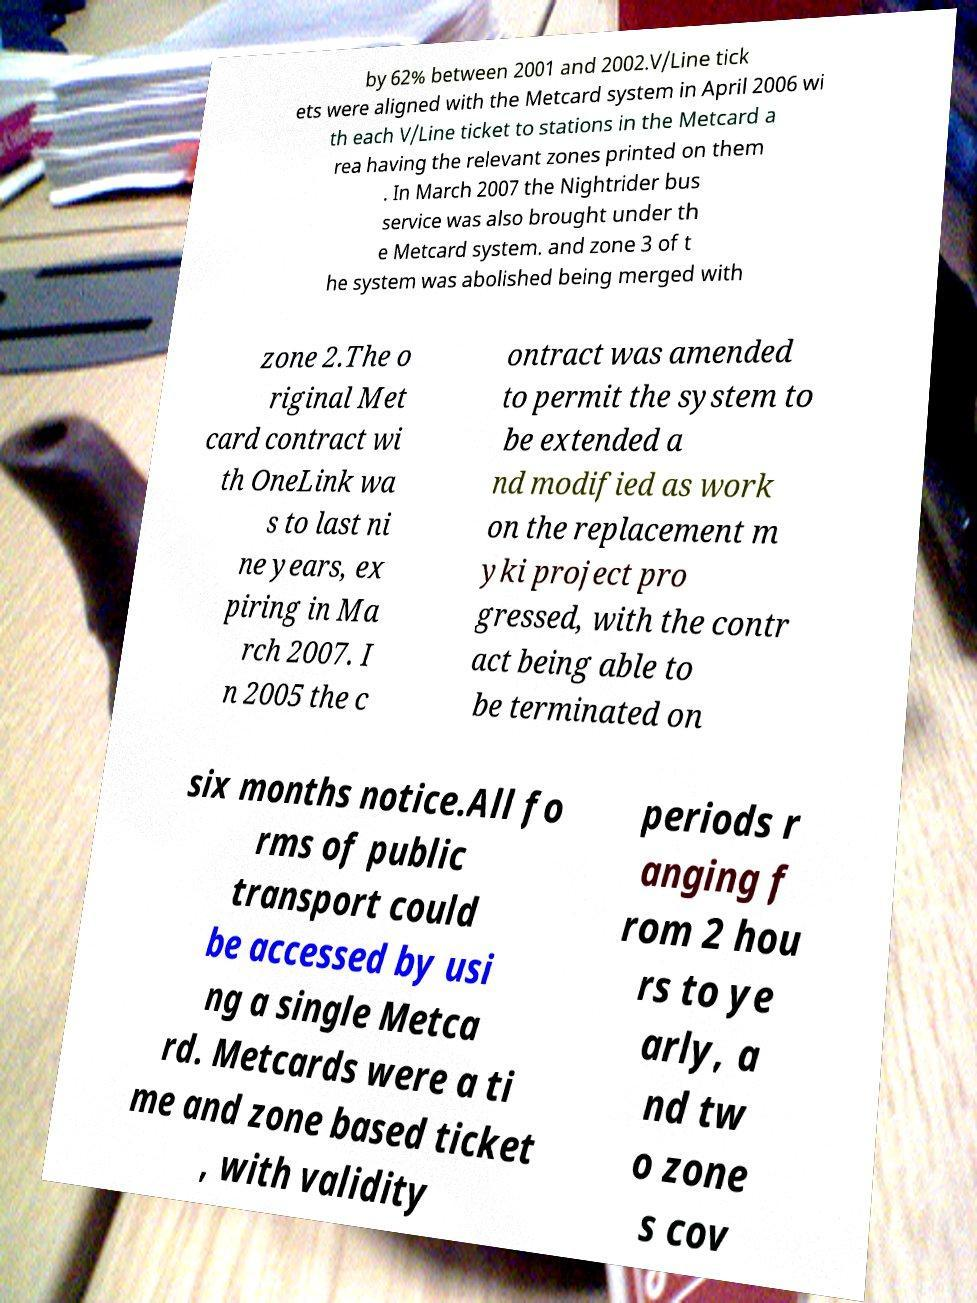Can you accurately transcribe the text from the provided image for me? by 62% between 2001 and 2002.V/Line tick ets were aligned with the Metcard system in April 2006 wi th each V/Line ticket to stations in the Metcard a rea having the relevant zones printed on them . In March 2007 the Nightrider bus service was also brought under th e Metcard system. and zone 3 of t he system was abolished being merged with zone 2.The o riginal Met card contract wi th OneLink wa s to last ni ne years, ex piring in Ma rch 2007. I n 2005 the c ontract was amended to permit the system to be extended a nd modified as work on the replacement m yki project pro gressed, with the contr act being able to be terminated on six months notice.All fo rms of public transport could be accessed by usi ng a single Metca rd. Metcards were a ti me and zone based ticket , with validity periods r anging f rom 2 hou rs to ye arly, a nd tw o zone s cov 